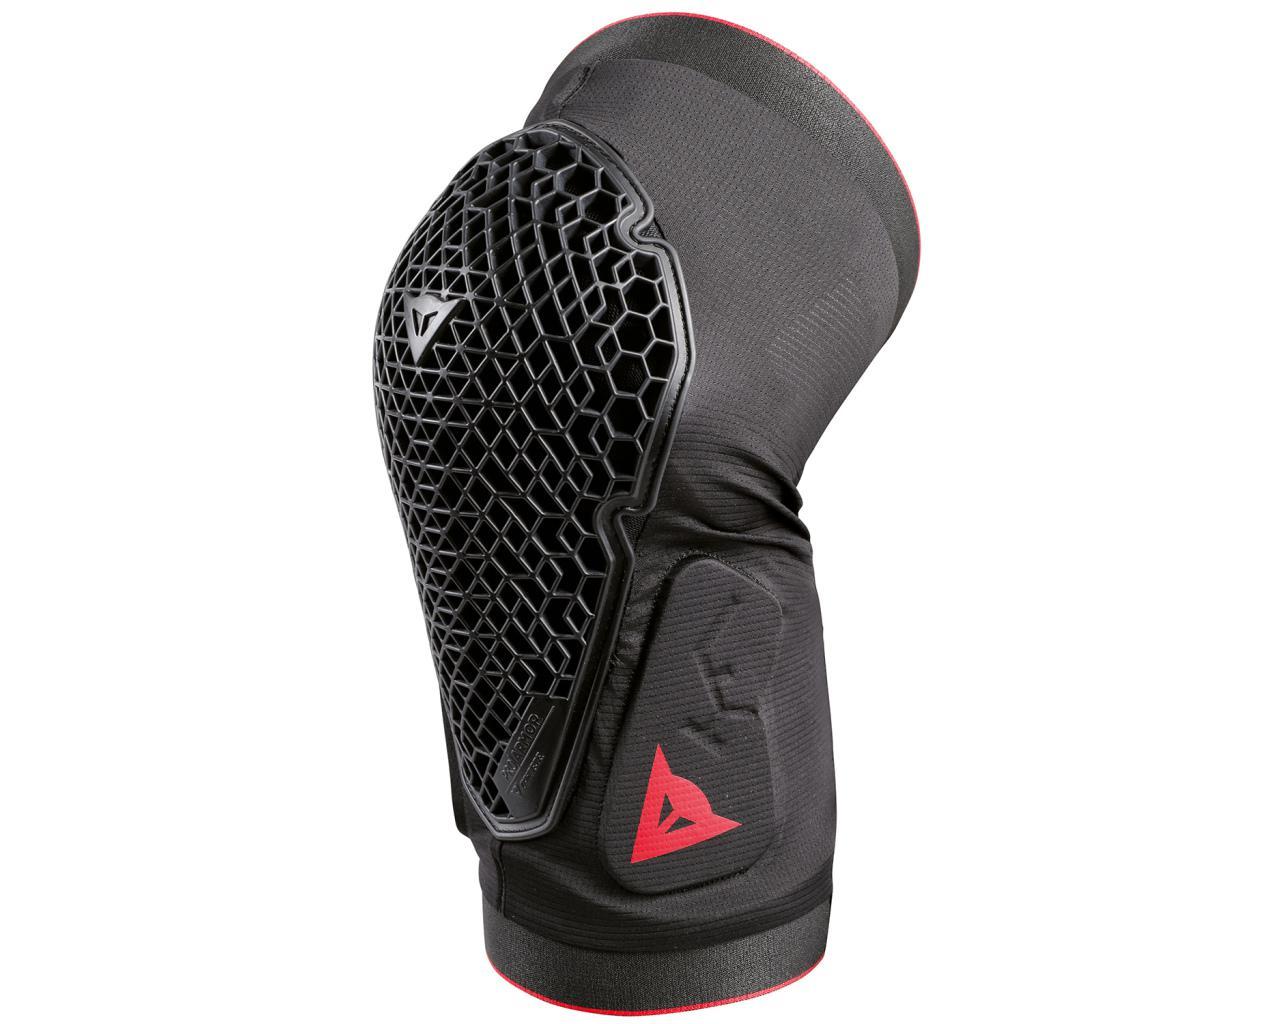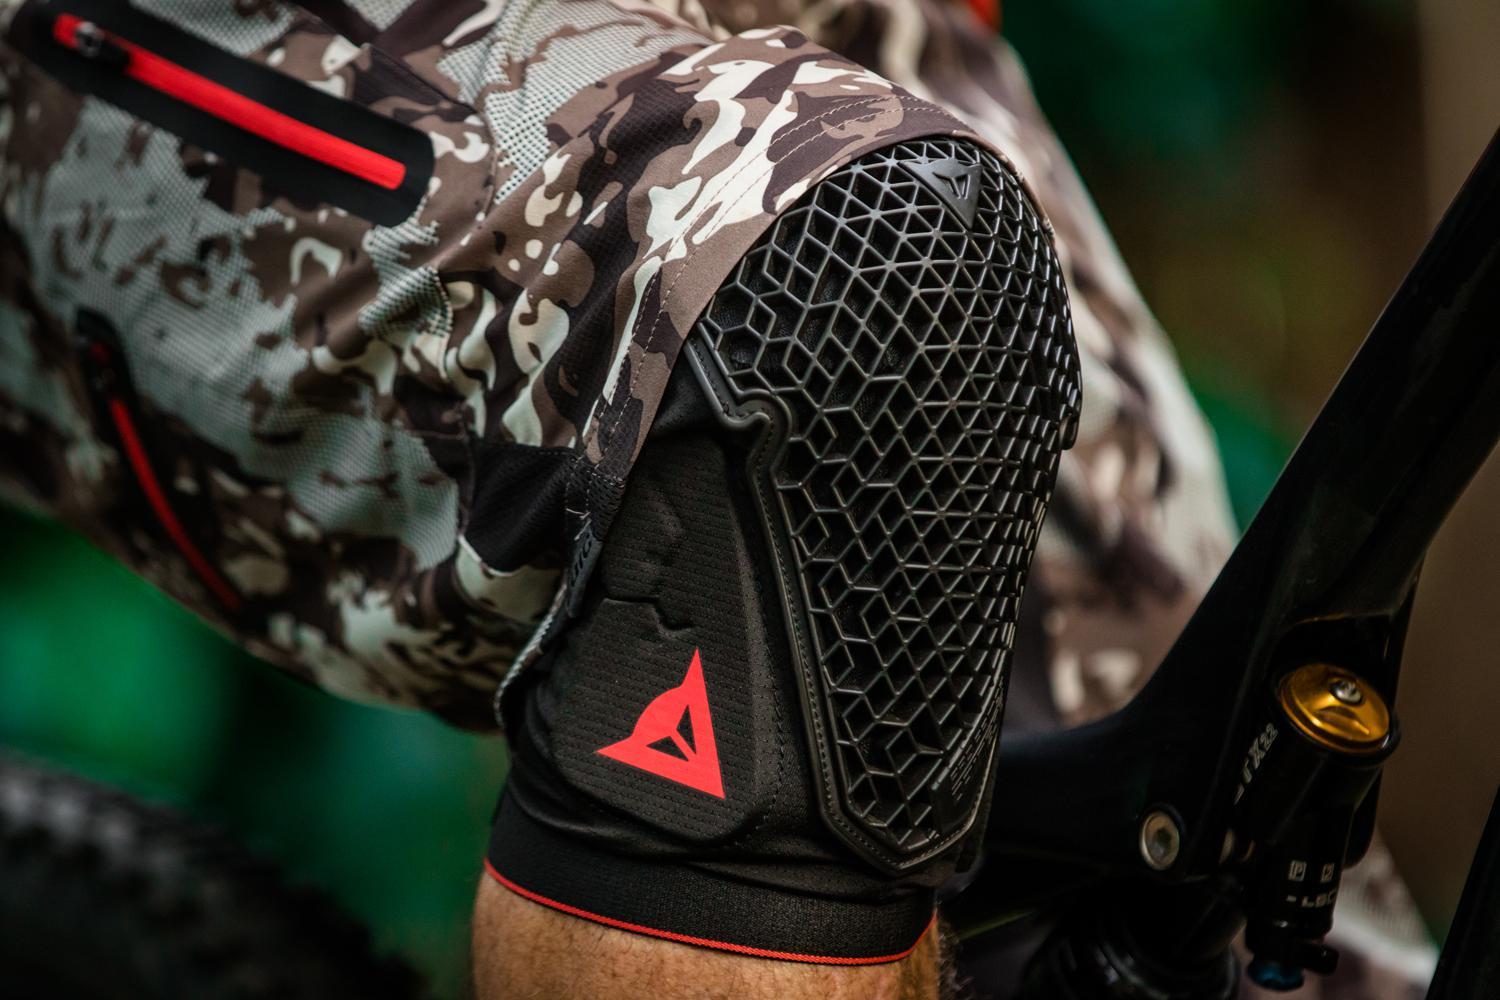The first image is the image on the left, the second image is the image on the right. Considering the images on both sides, is "Both images show kneepads modelled on human legs." valid? Answer yes or no. No. The first image is the image on the left, the second image is the image on the right. For the images displayed, is the sentence "An image shows a front view of a pair of legs wearing mesh-like kneepads." factually correct? Answer yes or no. No. 